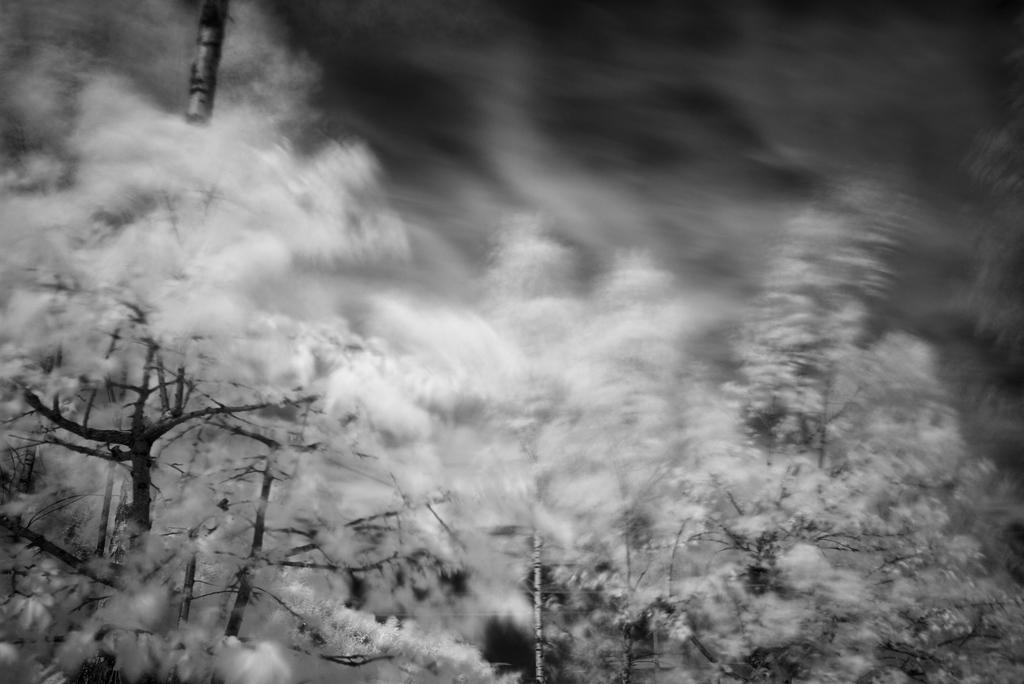Can you describe this image briefly? In this image we can see plants and snow on them. 